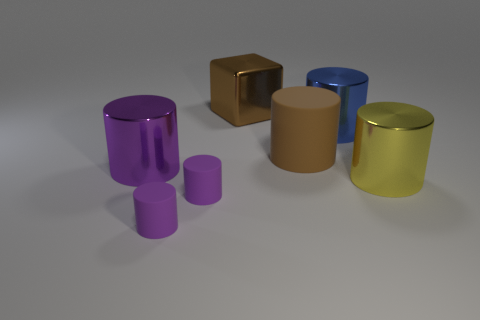How many purple cylinders must be subtracted to get 1 purple cylinders? 2 Subtract 1 brown blocks. How many objects are left? 6 Subtract all blocks. How many objects are left? 6 Subtract 1 cubes. How many cubes are left? 0 Subtract all yellow cylinders. Subtract all blue blocks. How many cylinders are left? 5 Subtract all yellow blocks. How many blue cylinders are left? 1 Subtract all brown objects. Subtract all big brown metal spheres. How many objects are left? 5 Add 6 small purple cylinders. How many small purple cylinders are left? 8 Add 2 cyan shiny balls. How many cyan shiny balls exist? 2 Add 2 gray cylinders. How many objects exist? 9 